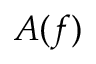<formula> <loc_0><loc_0><loc_500><loc_500>A ( f )</formula> 